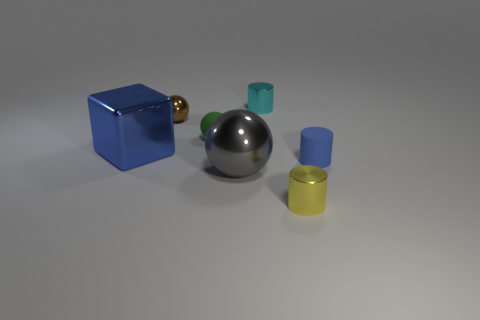What number of other things are made of the same material as the big gray object?
Offer a very short reply. 4. There is a large blue thing that is the same material as the cyan object; what shape is it?
Provide a short and direct response. Cube. Does the yellow shiny thing have the same size as the brown thing?
Provide a succinct answer. Yes. How big is the cylinder right of the tiny metal cylinder that is in front of the big ball?
Your answer should be compact. Small. What shape is the tiny matte object that is the same color as the large shiny cube?
Offer a very short reply. Cylinder. How many cylinders are small blue shiny things or large metallic things?
Provide a short and direct response. 0. Is the size of the blue rubber cylinder the same as the object that is in front of the big gray object?
Offer a terse response. Yes. Is the number of big cubes to the right of the green ball greater than the number of small cyan cylinders?
Your answer should be compact. No. There is a gray sphere that is the same material as the brown sphere; what is its size?
Offer a very short reply. Large. Are there any rubber cylinders that have the same color as the large metal ball?
Offer a terse response. No. 